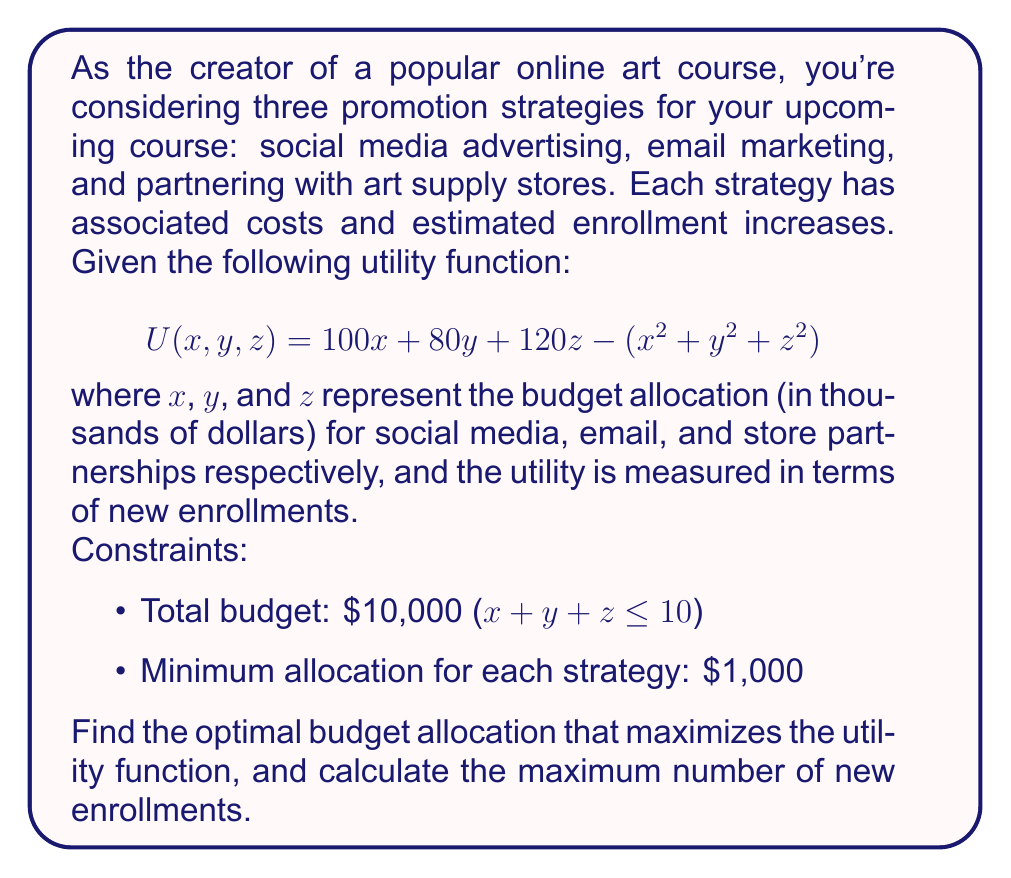Can you answer this question? To solve this problem, we'll use the method of Lagrange multipliers, as we have a constrained optimization problem.

Step 1: Set up the Lagrangian function
$$L(x, y, z, \lambda) = 100x + 80y + 120z - (x^2 + y^2 + z^2) - \lambda(x + y + z - 10)$$

Step 2: Take partial derivatives and set them equal to zero
$$\frac{\partial L}{\partial x} = 100 - 2x - \lambda = 0$$
$$\frac{\partial L}{\partial y} = 80 - 2y - \lambda = 0$$
$$\frac{\partial L}{\partial z} = 120 - 2z - \lambda = 0$$
$$\frac{\partial L}{\partial \lambda} = x + y + z - 10 = 0$$

Step 3: Solve the system of equations
From the first three equations:
$$x = 50 - \frac{\lambda}{2}$$
$$y = 40 - \frac{\lambda}{2}$$
$$z = 60 - \frac{\lambda}{2}$$

Substituting these into the fourth equation:
$$(50 - \frac{\lambda}{2}) + (40 - \frac{\lambda}{2}) + (60 - \frac{\lambda}{2}) = 10$$
$$150 - \frac{3\lambda}{2} = 10$$
$$\lambda = 93.33$$

Now we can find x, y, and z:
$$x = 50 - \frac{93.33}{2} = 3.33$$
$$y = 40 - \frac{93.33}{2} = -6.67$$
$$z = 60 - \frac{93.33}{2} = 13.33$$

Step 4: Check constraints and adjust
The solution violates our constraints (y is negative and z is greater than 10). We need to adjust our solution to meet the constraints.

Given the shape of our utility function (decreasing quadratic), the optimal solution will likely be at the boundary of our constraints. Let's allocate the minimum $1,000 to email marketing (y = 1) and distribute the remaining budget between x and z.

Our new problem becomes:
Maximize $$U(x, z) = 100x + 120z - (x^2 + z^2) + 80 - 1$$
Subject to $$x + z = 9$$ and $$x, z \geq 1$$

Step 5: Solve the new problem
Substitute z = 9 - x into the utility function:
$$U(x) = 100x + 120(9-x) - (x^2 + (9-x)^2) + 79$$
$$U(x) = 100x + 1080 - 120x - (x^2 + 81 - 18x + x^2) + 79$$
$$U(x) = -20x - 2x^2 + 18x + 1159$$
$$U(x) = -2x^2 + 2x + 1159$$

To find the maximum, differentiate and set to zero:
$$\frac{dU}{dx} = -4x + 2 = 0$$
$$x = 0.5$$

This x value is outside our constraint (x ≥ 1), so the maximum must occur at one of the boundaries. Let's check x = 1 and x = 8:

For x = 1: U(1) = -2 + 2 + 1159 = 1159
For x = 8: U(8) = -128 + 16 + 1159 = 1047

Step 6: Calculate the maximum utility
The maximum utility occurs when x = 1, z = 8, and y = 1.

U(1, 1, 8) = 100(1) + 80(1) + 120(8) - (1^2 + 1^2 + 8^2) = 1100

Therefore, the optimal budget allocation is:
Social media (x): $1,000
Email marketing (y): $1,000
Store partnerships (z): $8,000

The maximum number of new enrollments (utility) is 1,100.
Answer: Optimal allocation: $1,000 for social media, $1,000 for email marketing, $8,000 for store partnerships. Maximum new enrollments: 1,100. 